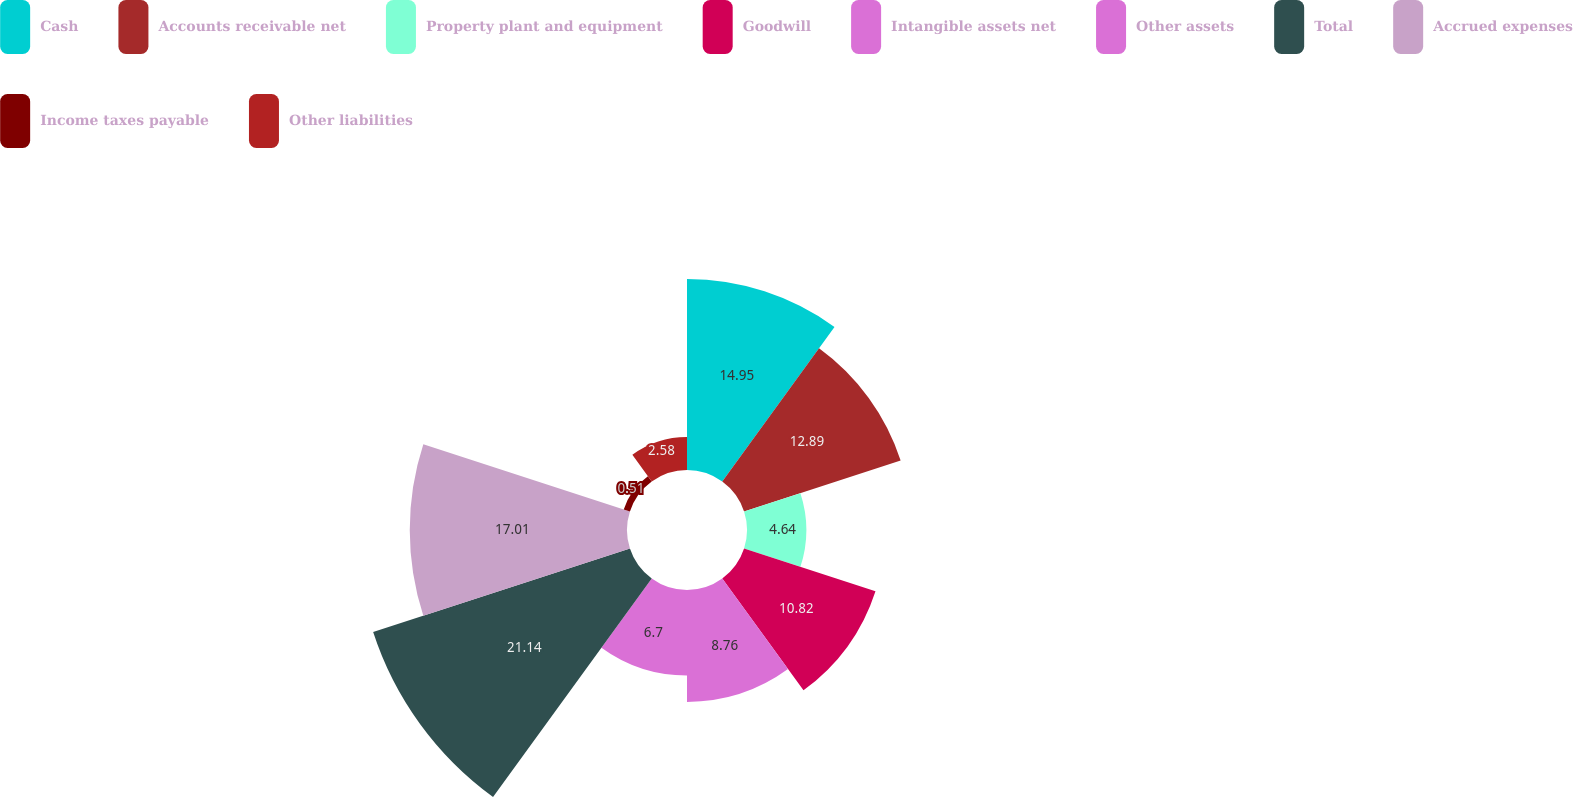<chart> <loc_0><loc_0><loc_500><loc_500><pie_chart><fcel>Cash<fcel>Accounts receivable net<fcel>Property plant and equipment<fcel>Goodwill<fcel>Intangible assets net<fcel>Other assets<fcel>Total<fcel>Accrued expenses<fcel>Income taxes payable<fcel>Other liabilities<nl><fcel>14.95%<fcel>12.89%<fcel>4.64%<fcel>10.82%<fcel>8.76%<fcel>6.7%<fcel>21.14%<fcel>17.01%<fcel>0.51%<fcel>2.58%<nl></chart> 